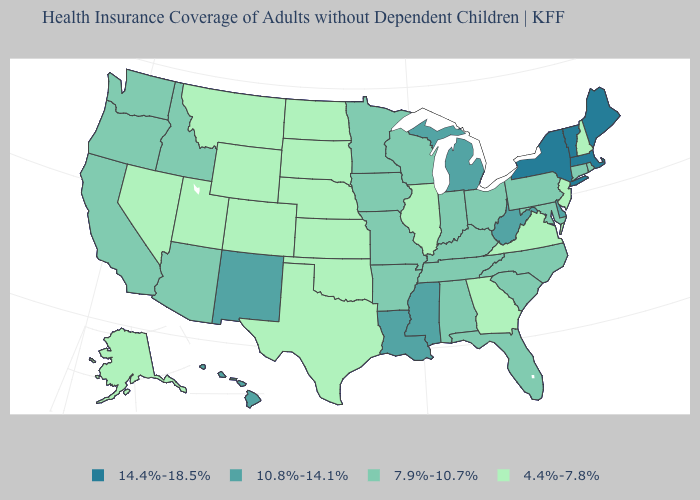Does Washington have a higher value than Virginia?
Answer briefly. Yes. Name the states that have a value in the range 10.8%-14.1%?
Quick response, please. Delaware, Hawaii, Louisiana, Michigan, Mississippi, New Mexico, West Virginia. Name the states that have a value in the range 4.4%-7.8%?
Concise answer only. Alaska, Colorado, Georgia, Illinois, Kansas, Montana, Nebraska, Nevada, New Hampshire, New Jersey, North Dakota, Oklahoma, South Dakota, Texas, Utah, Virginia, Wyoming. Name the states that have a value in the range 10.8%-14.1%?
Give a very brief answer. Delaware, Hawaii, Louisiana, Michigan, Mississippi, New Mexico, West Virginia. Name the states that have a value in the range 10.8%-14.1%?
Answer briefly. Delaware, Hawaii, Louisiana, Michigan, Mississippi, New Mexico, West Virginia. Does the map have missing data?
Short answer required. No. Does Rhode Island have the lowest value in the USA?
Answer briefly. No. What is the value of Mississippi?
Quick response, please. 10.8%-14.1%. Is the legend a continuous bar?
Concise answer only. No. What is the value of Ohio?
Short answer required. 7.9%-10.7%. What is the value of Illinois?
Quick response, please. 4.4%-7.8%. Does Alaska have a higher value than New Jersey?
Keep it brief. No. What is the value of Kansas?
Short answer required. 4.4%-7.8%. Name the states that have a value in the range 4.4%-7.8%?
Concise answer only. Alaska, Colorado, Georgia, Illinois, Kansas, Montana, Nebraska, Nevada, New Hampshire, New Jersey, North Dakota, Oklahoma, South Dakota, Texas, Utah, Virginia, Wyoming. Among the states that border Illinois , which have the lowest value?
Short answer required. Indiana, Iowa, Kentucky, Missouri, Wisconsin. 